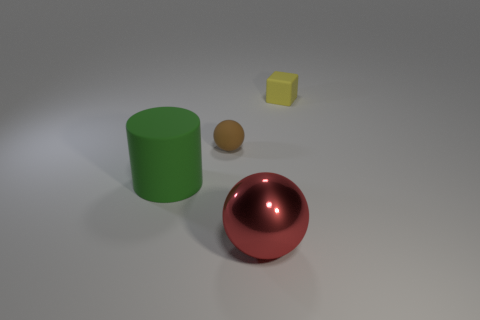Add 2 metal things. How many objects exist? 6 Subtract 1 balls. How many balls are left? 1 Subtract all brown spheres. How many spheres are left? 1 Subtract 0 cyan balls. How many objects are left? 4 Subtract all cubes. How many objects are left? 3 Subtract all purple balls. Subtract all yellow cylinders. How many balls are left? 2 Subtract all gray balls. How many brown cubes are left? 0 Subtract all rubber blocks. Subtract all big red objects. How many objects are left? 2 Add 4 yellow rubber objects. How many yellow rubber objects are left? 5 Add 2 matte blocks. How many matte blocks exist? 3 